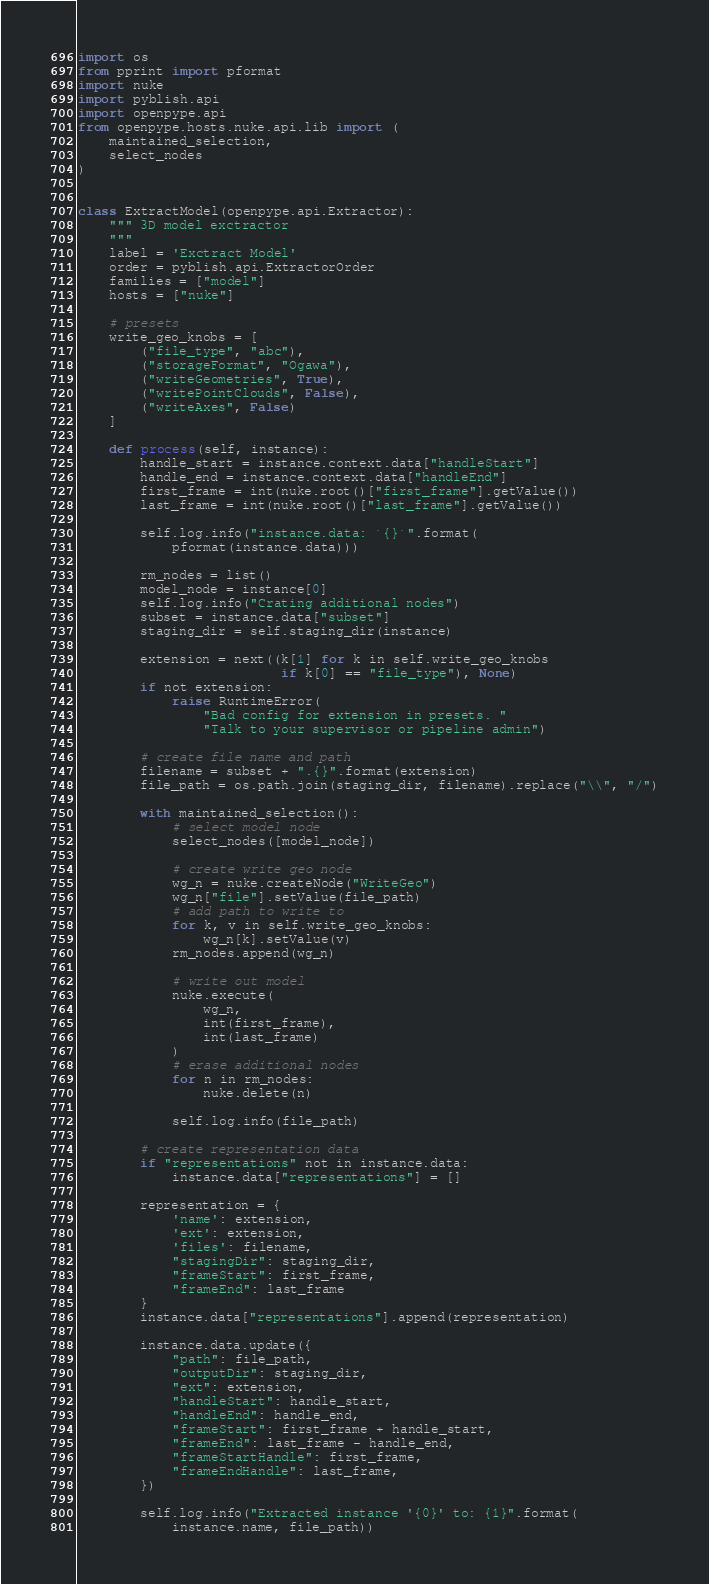Convert code to text. <code><loc_0><loc_0><loc_500><loc_500><_Python_>import os
from pprint import pformat
import nuke
import pyblish.api
import openpype.api
from openpype.hosts.nuke.api.lib import (
    maintained_selection,
    select_nodes
)


class ExtractModel(openpype.api.Extractor):
    """ 3D model exctractor
    """
    label = 'Exctract Model'
    order = pyblish.api.ExtractorOrder
    families = ["model"]
    hosts = ["nuke"]

    # presets
    write_geo_knobs = [
        ("file_type", "abc"),
        ("storageFormat", "Ogawa"),
        ("writeGeometries", True),
        ("writePointClouds", False),
        ("writeAxes", False)
    ]

    def process(self, instance):
        handle_start = instance.context.data["handleStart"]
        handle_end = instance.context.data["handleEnd"]
        first_frame = int(nuke.root()["first_frame"].getValue())
        last_frame = int(nuke.root()["last_frame"].getValue())

        self.log.info("instance.data: `{}`".format(
            pformat(instance.data)))

        rm_nodes = list()
        model_node = instance[0]
        self.log.info("Crating additional nodes")
        subset = instance.data["subset"]
        staging_dir = self.staging_dir(instance)

        extension = next((k[1] for k in self.write_geo_knobs
                          if k[0] == "file_type"), None)
        if not extension:
            raise RuntimeError(
                "Bad config for extension in presets. "
                "Talk to your supervisor or pipeline admin")

        # create file name and path
        filename = subset + ".{}".format(extension)
        file_path = os.path.join(staging_dir, filename).replace("\\", "/")

        with maintained_selection():
            # select model node
            select_nodes([model_node])

            # create write geo node
            wg_n = nuke.createNode("WriteGeo")
            wg_n["file"].setValue(file_path)
            # add path to write to
            for k, v in self.write_geo_knobs:
                wg_n[k].setValue(v)
            rm_nodes.append(wg_n)

            # write out model
            nuke.execute(
                wg_n,
                int(first_frame),
                int(last_frame)
            )
            # erase additional nodes
            for n in rm_nodes:
                nuke.delete(n)

            self.log.info(file_path)

        # create representation data
        if "representations" not in instance.data:
            instance.data["representations"] = []

        representation = {
            'name': extension,
            'ext': extension,
            'files': filename,
            "stagingDir": staging_dir,
            "frameStart": first_frame,
            "frameEnd": last_frame
        }
        instance.data["representations"].append(representation)

        instance.data.update({
            "path": file_path,
            "outputDir": staging_dir,
            "ext": extension,
            "handleStart": handle_start,
            "handleEnd": handle_end,
            "frameStart": first_frame + handle_start,
            "frameEnd": last_frame - handle_end,
            "frameStartHandle": first_frame,
            "frameEndHandle": last_frame,
        })

        self.log.info("Extracted instance '{0}' to: {1}".format(
            instance.name, file_path))
</code> 